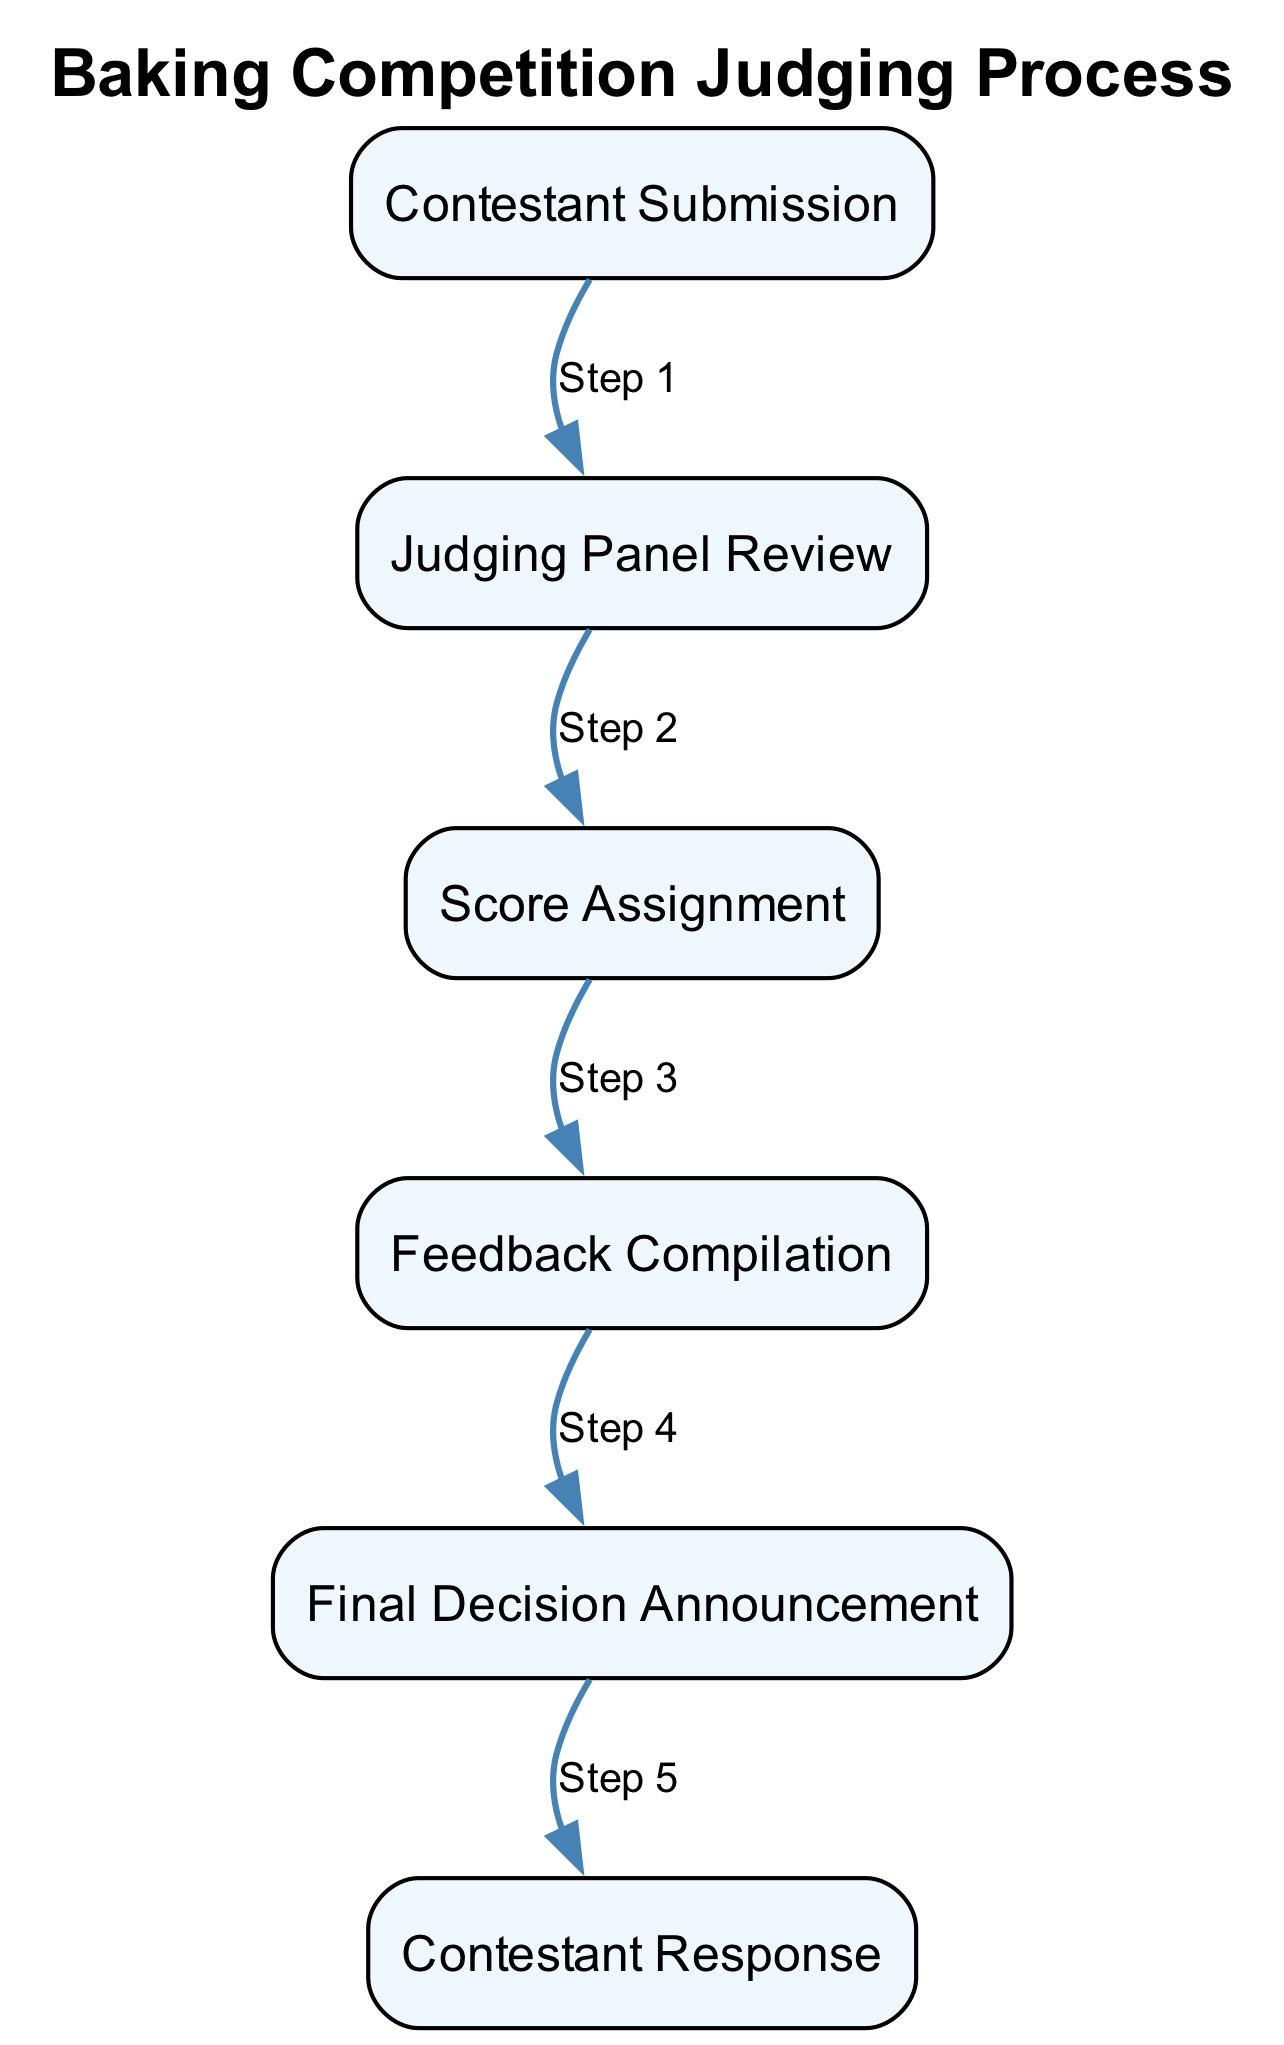What is the first step in the baking competition judging process? The first step in the flow is "Contestant Submission." This is the starting point where contestants submit their baked goods for judging.
Answer: Contestant Submission How many elements are there in the judging process diagram? By counting the listed elements, there are a total of six distinct steps in the diagram representing the judging process.
Answer: 6 Which step comes after "Score Assignment"? Following "Score Assignment," the next step is "Feedback Compilation," indicating that judges provide feedback after scores are assigned.
Answer: Feedback Compilation What is the last step in the judging process? The last step is "Final Decision Announcement," as it represents the conclusion of the judging process where winners are announced.
Answer: Final Decision Announcement Which two nodes are directly connected to "Judging Panel Review"? "Contestant Submission" feeds into "Judging Panel Review," and then it directly connects to "Score Assignment," thus linking these three elements.
Answer: Contestant Submission, Score Assignment What type of feedback is given after "Score Assignment"? The feedback provided is called "compiled feedback," which judges compile for each contestant regarding their baked goods, focusing on various attributes.
Answer: Feedback Compilation How many connections are there in total between the steps? Counting the visible and invisible edges that connect the six steps in the sequence diagram gives a total of seven connections in the process.
Answer: 7 Which step comes immediately before the "Final Decision Announcement"? Immediately before the final announcement, judges compile feedback, making "Feedback Compilation" the penultimate step in the judging process.
Answer: Feedback Compilation 